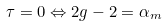<formula> <loc_0><loc_0><loc_500><loc_500>\tau = 0 \Leftrightarrow 2 g - 2 = \alpha _ { m }</formula> 